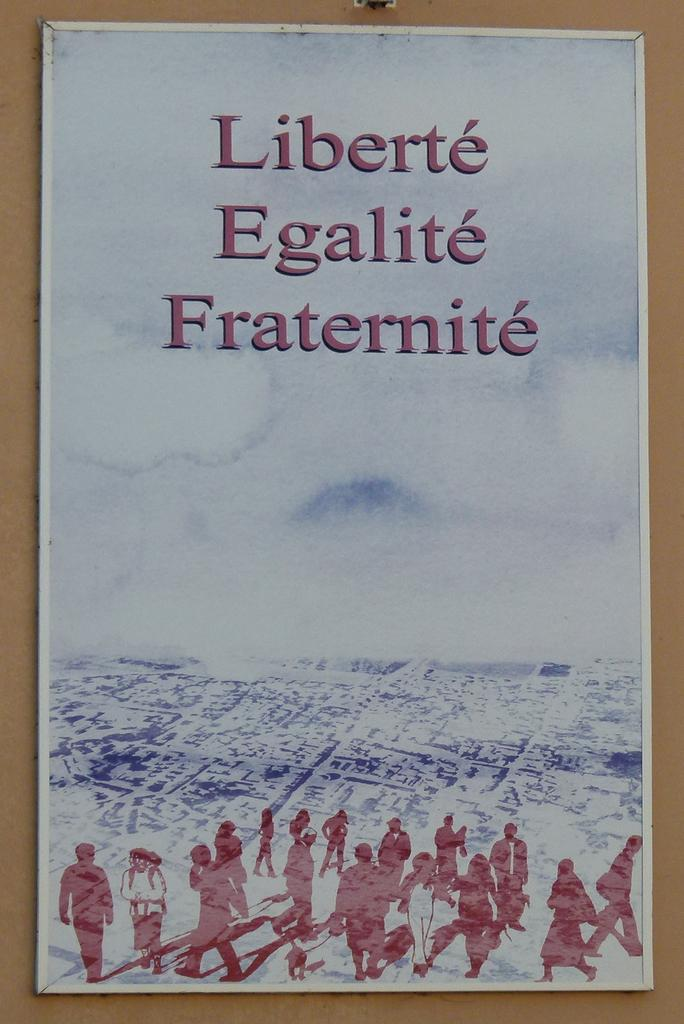<image>
Share a concise interpretation of the image provided. A bland poster taped to a wall reads Liberte, Egalite, Fraternite. 